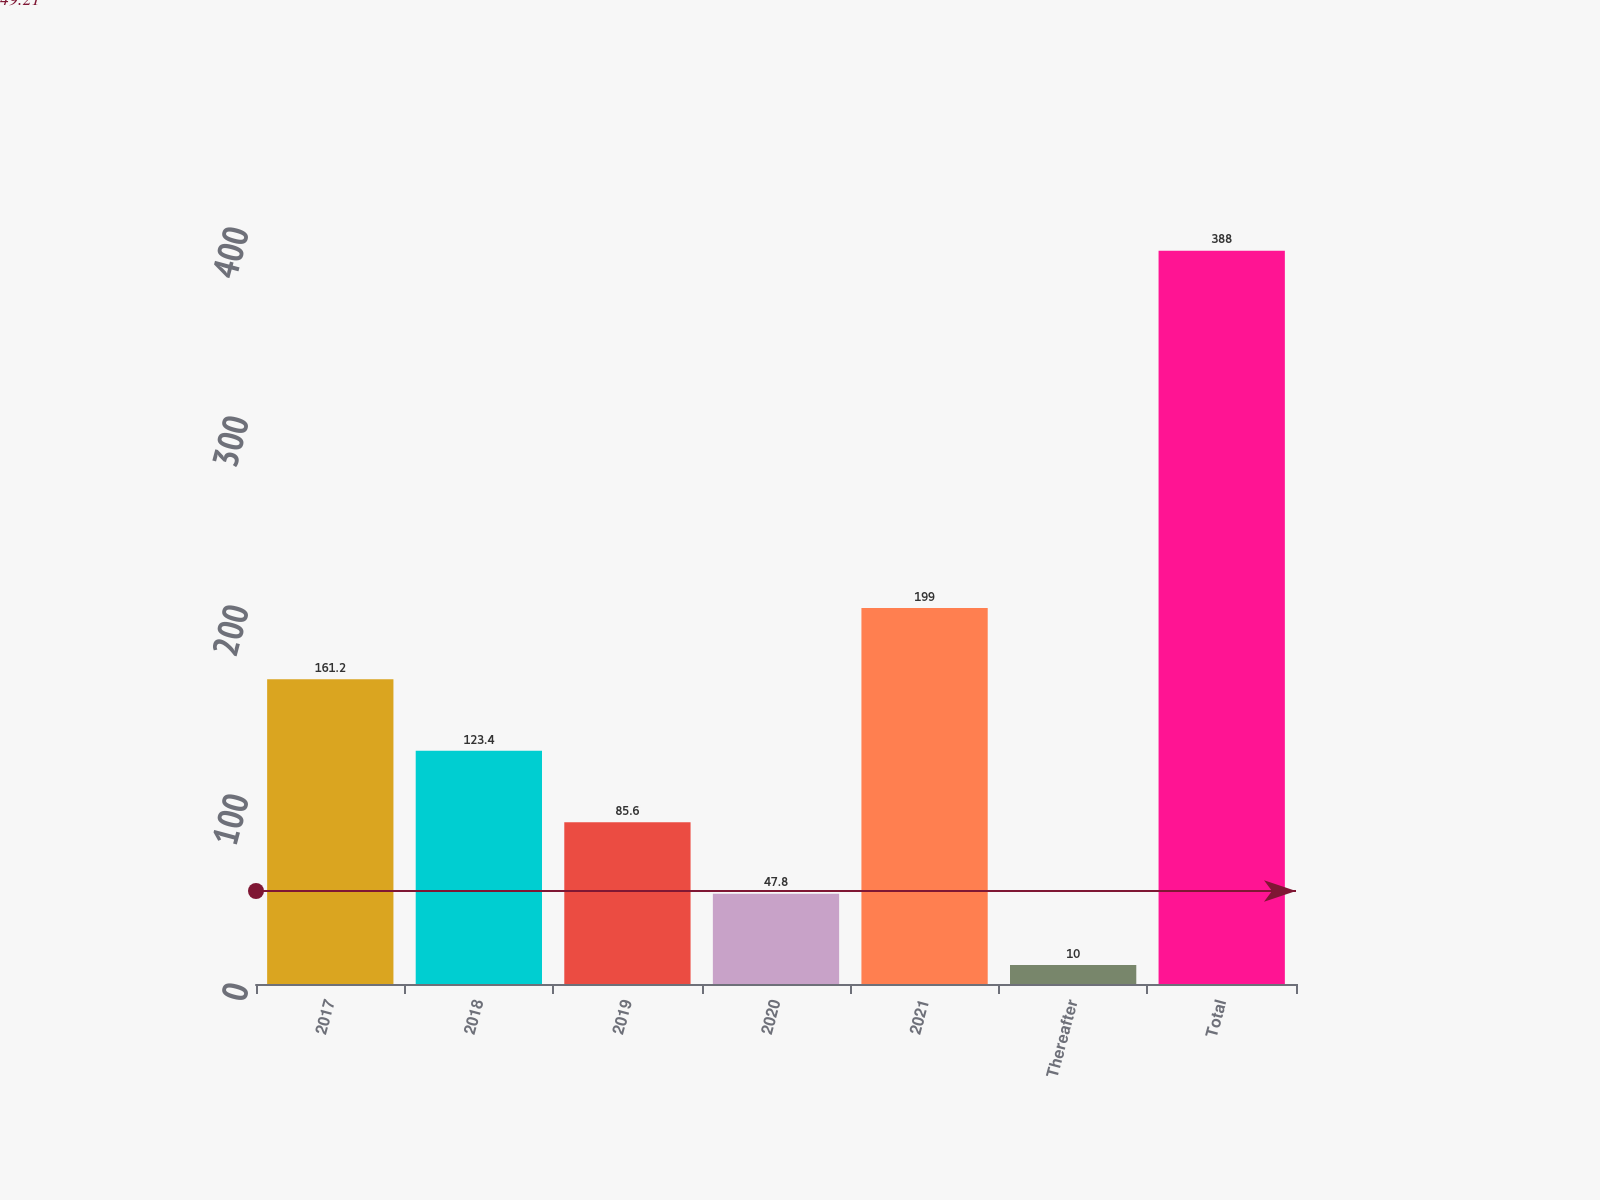Convert chart to OTSL. <chart><loc_0><loc_0><loc_500><loc_500><bar_chart><fcel>2017<fcel>2018<fcel>2019<fcel>2020<fcel>2021<fcel>Thereafter<fcel>Total<nl><fcel>161.2<fcel>123.4<fcel>85.6<fcel>47.8<fcel>199<fcel>10<fcel>388<nl></chart> 